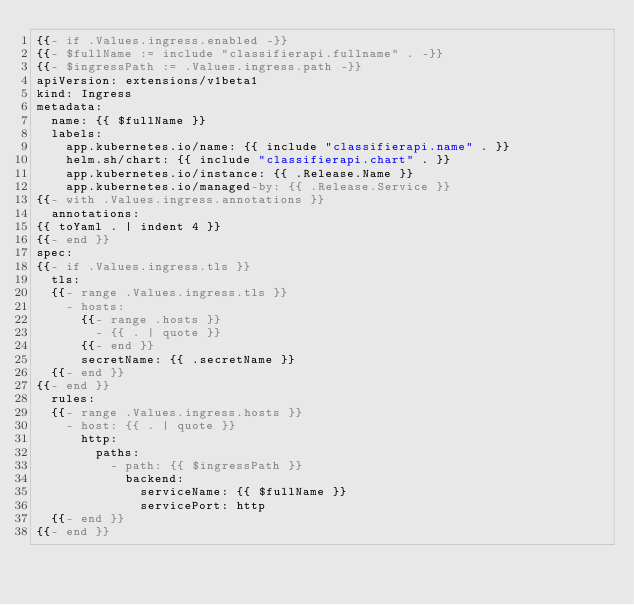Convert code to text. <code><loc_0><loc_0><loc_500><loc_500><_YAML_>{{- if .Values.ingress.enabled -}}
{{- $fullName := include "classifierapi.fullname" . -}}
{{- $ingressPath := .Values.ingress.path -}}
apiVersion: extensions/v1beta1
kind: Ingress
metadata:
  name: {{ $fullName }}
  labels:
    app.kubernetes.io/name: {{ include "classifierapi.name" . }}
    helm.sh/chart: {{ include "classifierapi.chart" . }}
    app.kubernetes.io/instance: {{ .Release.Name }}
    app.kubernetes.io/managed-by: {{ .Release.Service }}
{{- with .Values.ingress.annotations }}
  annotations:
{{ toYaml . | indent 4 }}
{{- end }}
spec:
{{- if .Values.ingress.tls }}
  tls:
  {{- range .Values.ingress.tls }}
    - hosts:
      {{- range .hosts }}
        - {{ . | quote }}
      {{- end }}
      secretName: {{ .secretName }}
  {{- end }}
{{- end }}
  rules:
  {{- range .Values.ingress.hosts }}
    - host: {{ . | quote }}
      http:
        paths:
          - path: {{ $ingressPath }}
            backend:
              serviceName: {{ $fullName }}
              servicePort: http
  {{- end }}
{{- end }}
</code> 